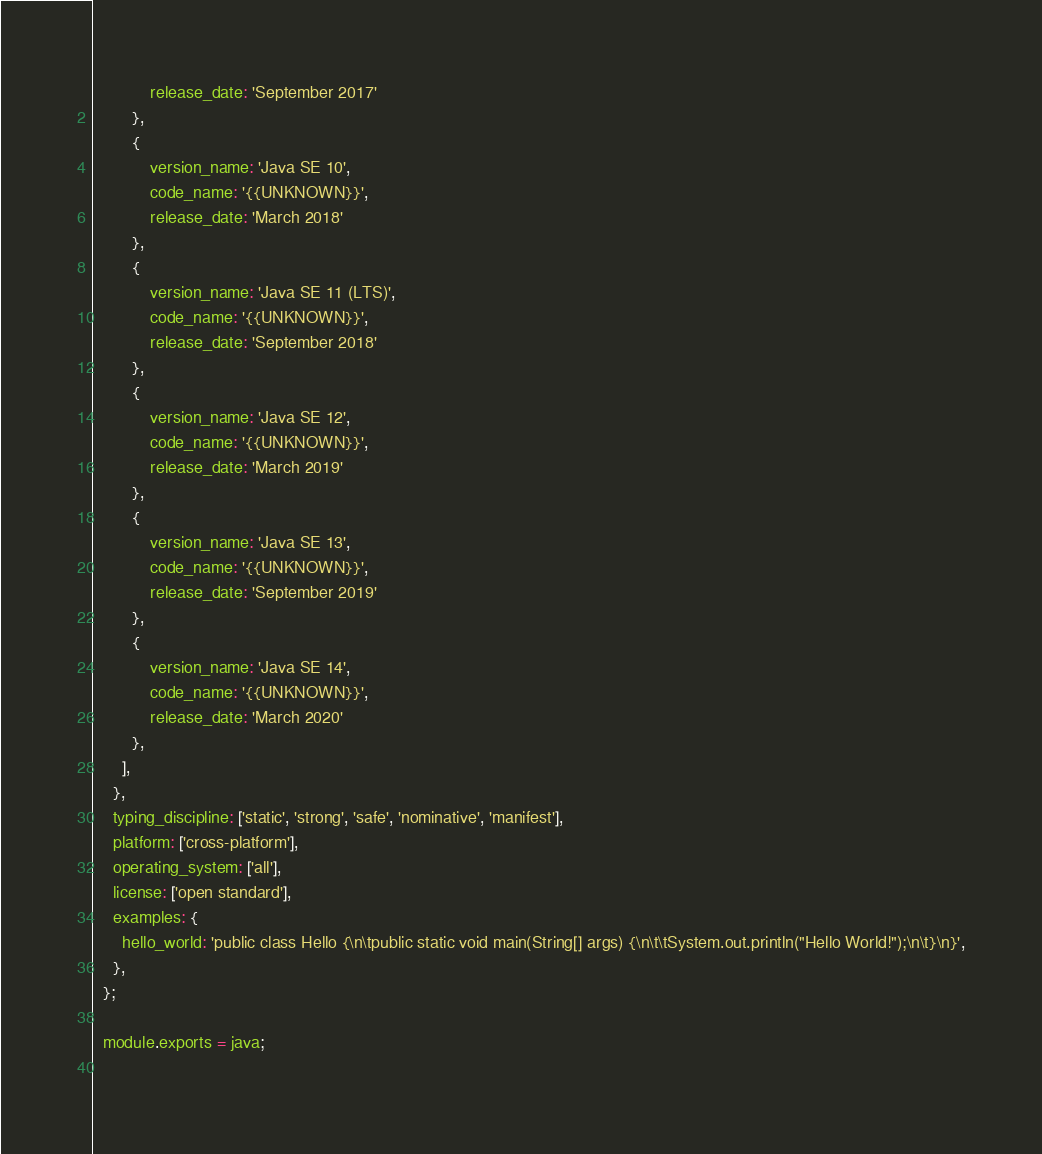<code> <loc_0><loc_0><loc_500><loc_500><_JavaScript_>            release_date: 'September 2017'
        },
        {
            version_name: 'Java SE 10',
            code_name: '{{UNKNOWN}}',
            release_date: 'March 2018'
        },
        {
            version_name: 'Java SE 11 (LTS)',
            code_name: '{{UNKNOWN}}',
            release_date: 'September 2018'
        },
        {
            version_name: 'Java SE 12',
            code_name: '{{UNKNOWN}}',
            release_date: 'March 2019'
        },
        {
            version_name: 'Java SE 13',
            code_name: '{{UNKNOWN}}',
            release_date: 'September 2019'
        },
        {
            version_name: 'Java SE 14',
            code_name: '{{UNKNOWN}}',
            release_date: 'March 2020'
        },
      ],
    },
    typing_discipline: ['static', 'strong', 'safe', 'nominative', 'manifest'],
    platform: ['cross-platform'],
    operating_system: ['all'],
    license: ['open standard'],
    examples: {
      hello_world: 'public class Hello {\n\tpublic static void main(String[] args) {\n\t\tSystem.out.println("Hello World!");\n\t}\n}',
    },
  };
  
  module.exports = java;
  </code> 